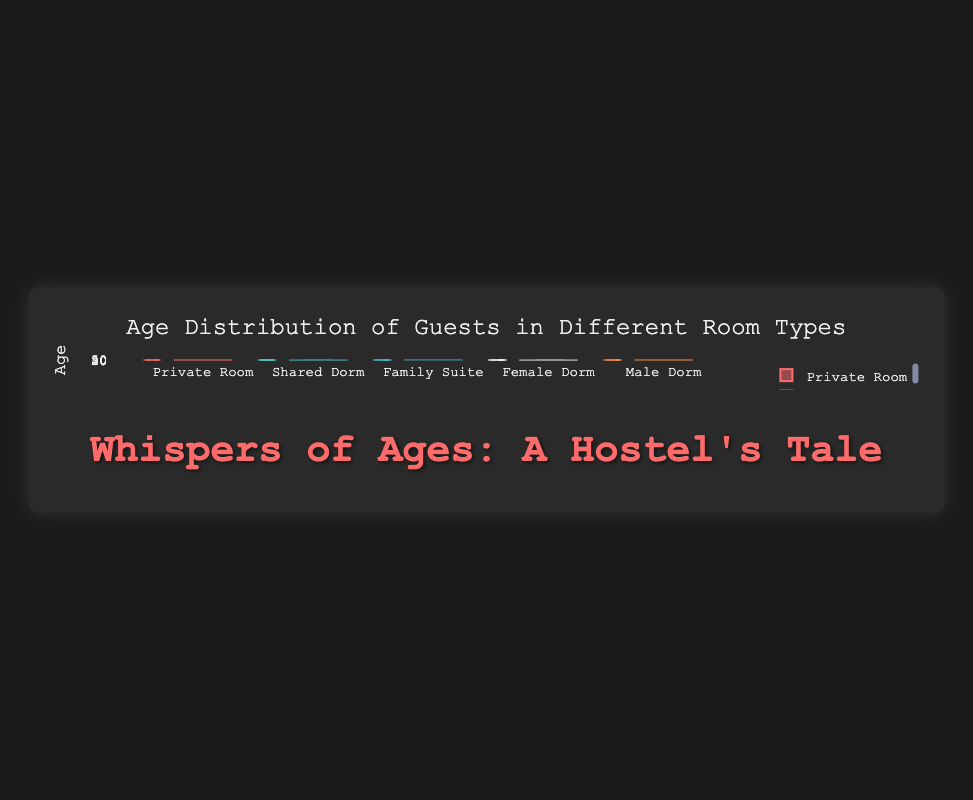What is the title of the figure? The title of the figure can be found at the top of the plot, which is "Age Distribution of Guests in Different Room Types".
Answer: Age Distribution of Guests in Different Room Types How is the data represented in the plot? The data is represented using box plots, one for each room type. Each box plot shows the age distribution of guests in that room category.
Answer: Using box plots What is the age range for guests staying in the Private Room? Look at the box plot for the Private Room and note the minimum and maximum values of the whiskers. The minimum is 27, and the maximum is 41.
Answer: 27 to 41 Which room type has the widest age range? To find the room type with the widest age range, compare the distance between the minimum and maximum values of the whiskers for each box plot. The Family Suite has an age range from 38 to 47, which is the widest.
Answer: Family Suite What is the median age of guests in the Male Dorm? Identify the line inside the box for the Male Dorm box plot, which represents the median. It corresponds to the value 30.
Answer: 30 Which room type has the lowest median age? Look at the lines inside each box for all room types and find the smallest median value. The Shared Dorm has the lowest median age around 24.
Answer: Shared Dorm Compare the median age of guests in the Female Dorm and Shared Dorm. Check the line inside the box for each box plot. The Female Dorm has a median age of 24, equivalent to Shared Dorm.
Answer: Equal What is the difference in the upper quartiles between the Private Room and the Family Suite? The upper quartile is indicated by the top of the box. For Private Room, it's 35, and for Family Suite, it's 45. The difference is 45 - 35 = 10.
Answer: 10 Which room type has the smallest interquartile range (IQR)? The IQR is the distance between the lower and upper quartiles. Check each box plot and see which has the smallest box height. The Female Dorm has the smallest IQR.
Answer: Female Dorm What is the age of the oldest guest in the Shared Dorm? Look at the maximum value on the whisker for the Shared Dorm box plot. The maximum value is 30.
Answer: 30 